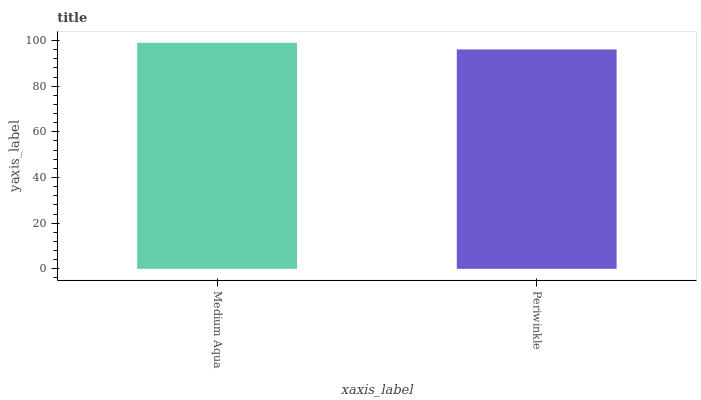Is Periwinkle the minimum?
Answer yes or no. Yes. Is Medium Aqua the maximum?
Answer yes or no. Yes. Is Periwinkle the maximum?
Answer yes or no. No. Is Medium Aqua greater than Periwinkle?
Answer yes or no. Yes. Is Periwinkle less than Medium Aqua?
Answer yes or no. Yes. Is Periwinkle greater than Medium Aqua?
Answer yes or no. No. Is Medium Aqua less than Periwinkle?
Answer yes or no. No. Is Medium Aqua the high median?
Answer yes or no. Yes. Is Periwinkle the low median?
Answer yes or no. Yes. Is Periwinkle the high median?
Answer yes or no. No. Is Medium Aqua the low median?
Answer yes or no. No. 